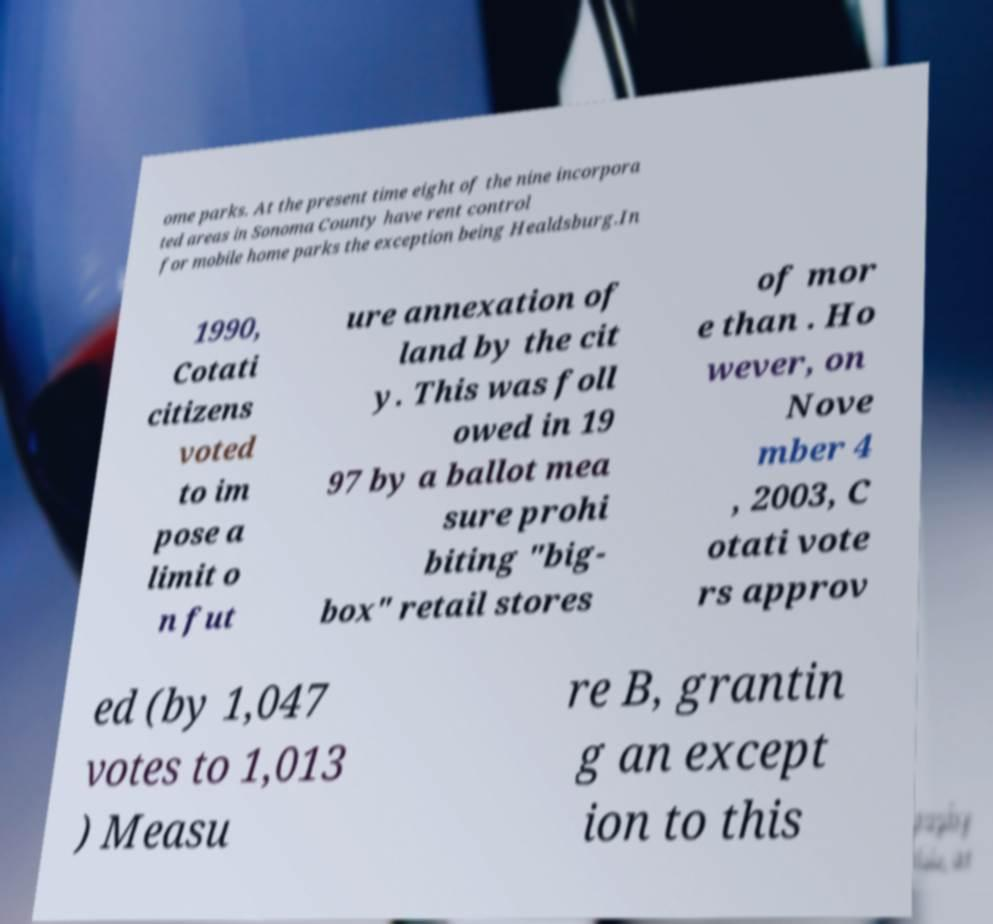Can you read and provide the text displayed in the image?This photo seems to have some interesting text. Can you extract and type it out for me? ome parks. At the present time eight of the nine incorpora ted areas in Sonoma County have rent control for mobile home parks the exception being Healdsburg.In 1990, Cotati citizens voted to im pose a limit o n fut ure annexation of land by the cit y. This was foll owed in 19 97 by a ballot mea sure prohi biting "big- box" retail stores of mor e than . Ho wever, on Nove mber 4 , 2003, C otati vote rs approv ed (by 1,047 votes to 1,013 ) Measu re B, grantin g an except ion to this 